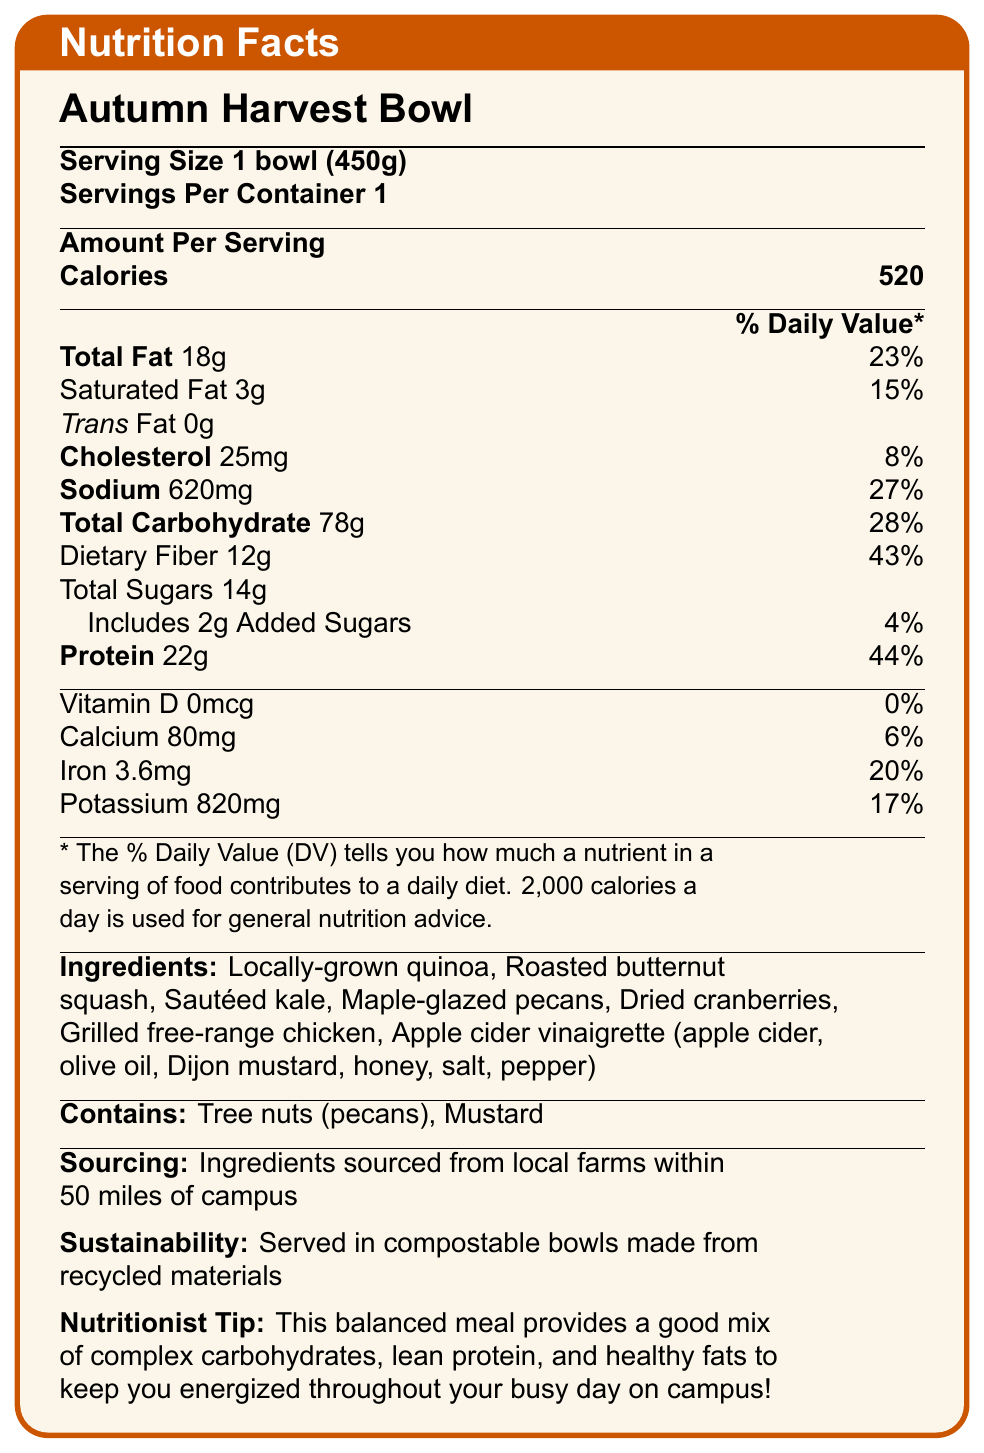what is the serving size? The serving size is mentioned at the beginning of the nutritional information under the product name.
Answer: 1 bowl (450g) how many calories are in one serving? The number of calories per serving is directly listed next to the "Amount Per Serving" section under "Calories."
Answer: 520 calories what is the total fat content, and its percentage of the daily value? The total fat content is listed as 18g, and its percentage of the daily value is 23%, as shown under "Total Fat."
Answer: 18g, 23% how much dietary fiber does the Autumn Harvest Bowl contain? The dietary fiber content is indicated as 12g under the "Total Carbohydrate" section.
Answer: 12g what are the two allergens listed in the Autumn Harvest Bowl? The allergens are mentioned at the bottom of the document under the "Contains" section.
Answer: Tree nuts (pecans), Mustard how much protein is there in one serving, and what is its % daily value? The protein content is listed as 22g and has a 44% daily value as shown under "Protein."
Answer: 22g, 44% which ingredient is not a plant-based ingredient in the Autumn Harvest Bowl? All other ingredients are plant-based, while "Grilled free-range chicken" is not.
Answer: Grilled free-range chicken which of the following vitamins and minerals has the highest daily value percentage? A. Vitamin D B. Calcium C. Iron D. Potassium Vitamin D is 0%, Calcium is 6%, Iron is 20%, and Potassium is 17%. Iron has the highest daily value percentage.
Answer: C. Iron what is the primary benefit of this meal according to the nutritionist tip? A. High in calories B. Provides a mix of complex carbohydrates, lean protein, and healthy fats C. Low in sodium D. High in vitamin D The nutritionist tip suggests that this meal provides a balanced mix of complex carbohydrates, lean protein, and healthy fats.
Answer: B. Provides a mix of complex carbohydrates, lean protein, and healthy fats is this meal served in eco-friendly packaging? The "Sustainability" section mentions that it is served in compostable bowls made from recycled materials.
Answer: Yes summarize the main idea of the nutrition facts label. The document provides detailed nutritional information, ingredients, allergens, and additional information regarding sourcing and sustainability of this special edition dish.
Answer: The Autumn Harvest Bowl is a nutritious meal featuring local, seasonal ingredients, providing a balanced mix of complex carbohydrates, lean protein, and healthy fats. It contains 520 calories per serving, with significant amounts of vitamins and minerals. The meal is also eco-friendly and highlights allergens such as tree nuts and mustard. how many grams of added sugars are in the Autumn Harvest Bowl? Under "Total Sugars," it is mentioned that the meal includes 2g of added sugars.
Answer: 2g does the Autumn Harvest Bowl contain any trans fat? The "Trans Fat" content is listed as 0g.
Answer: No what is the source of the apple cider vinaigrette used in the Autumn Harvest Bowl? The document lists the ingredients of the vinaigrette but does not specify its source.
Answer: Cannot be determined 